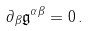<formula> <loc_0><loc_0><loc_500><loc_500>\partial _ { \beta } \mathfrak { g } ^ { \alpha \beta } = 0 \, .</formula> 